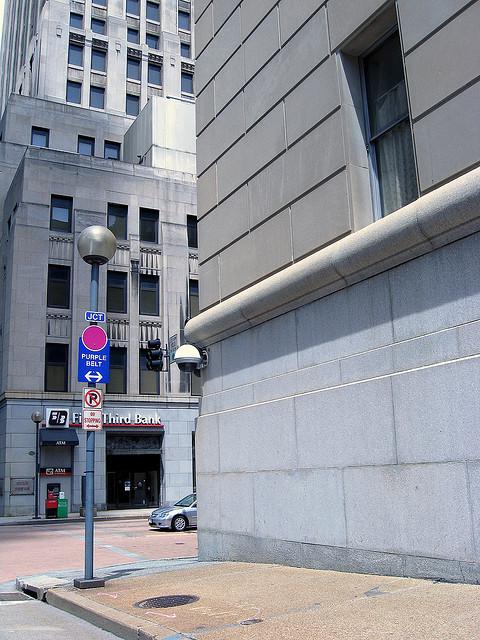What is the name of the business in the background near the car?
Quick response, please. Third bank. How many people are in the photo?
Concise answer only. 0. What sign is this?
Write a very short answer. No parking. How much is the meter?
Answer briefly. 25. What is the blue object on the side of the building?
Keep it brief. Sign. 